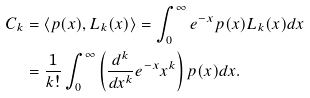<formula> <loc_0><loc_0><loc_500><loc_500>C _ { k } & = \left < p ( x ) , L _ { k } ( x ) \right > = \int _ { 0 } ^ { \infty } e ^ { - x } p ( x ) L _ { k } ( x ) d x \\ & = \frac { 1 } { k ! } \int _ { 0 } ^ { \infty } \left ( \frac { d ^ { k } } { d x ^ { k } } e ^ { - x } x ^ { k } \right ) p ( x ) d x .</formula> 